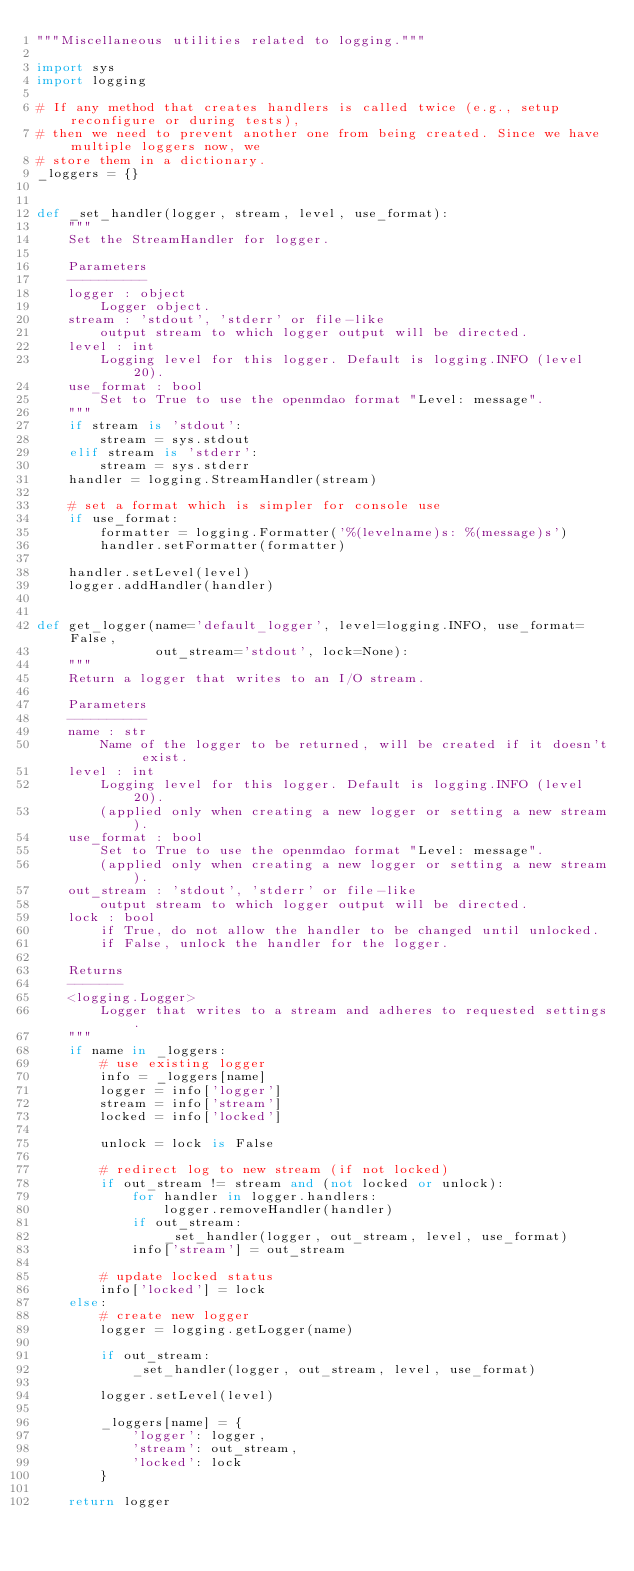<code> <loc_0><loc_0><loc_500><loc_500><_Python_>"""Miscellaneous utilities related to logging."""

import sys
import logging

# If any method that creates handlers is called twice (e.g., setup reconfigure or during tests),
# then we need to prevent another one from being created. Since we have multiple loggers now, we
# store them in a dictionary.
_loggers = {}


def _set_handler(logger, stream, level, use_format):
    """
    Set the StreamHandler for logger.

    Parameters
    ----------
    logger : object
        Logger object.
    stream : 'stdout', 'stderr' or file-like
        output stream to which logger output will be directed.
    level : int
        Logging level for this logger. Default is logging.INFO (level 20).
    use_format : bool
        Set to True to use the openmdao format "Level: message".
    """
    if stream is 'stdout':
        stream = sys.stdout
    elif stream is 'stderr':
        stream = sys.stderr
    handler = logging.StreamHandler(stream)

    # set a format which is simpler for console use
    if use_format:
        formatter = logging.Formatter('%(levelname)s: %(message)s')
        handler.setFormatter(formatter)

    handler.setLevel(level)
    logger.addHandler(handler)


def get_logger(name='default_logger', level=logging.INFO, use_format=False,
               out_stream='stdout', lock=None):
    """
    Return a logger that writes to an I/O stream.

    Parameters
    ----------
    name : str
        Name of the logger to be returned, will be created if it doesn't exist.
    level : int
        Logging level for this logger. Default is logging.INFO (level 20).
        (applied only when creating a new logger or setting a new stream).
    use_format : bool
        Set to True to use the openmdao format "Level: message".
        (applied only when creating a new logger or setting a new stream).
    out_stream : 'stdout', 'stderr' or file-like
        output stream to which logger output will be directed.
    lock : bool
        if True, do not allow the handler to be changed until unlocked.
        if False, unlock the handler for the logger.

    Returns
    -------
    <logging.Logger>
        Logger that writes to a stream and adheres to requested settings.
    """
    if name in _loggers:
        # use existing logger
        info = _loggers[name]
        logger = info['logger']
        stream = info['stream']
        locked = info['locked']

        unlock = lock is False

        # redirect log to new stream (if not locked)
        if out_stream != stream and (not locked or unlock):
            for handler in logger.handlers:
                logger.removeHandler(handler)
            if out_stream:
                _set_handler(logger, out_stream, level, use_format)
            info['stream'] = out_stream

        # update locked status
        info['locked'] = lock
    else:
        # create new logger
        logger = logging.getLogger(name)

        if out_stream:
            _set_handler(logger, out_stream, level, use_format)

        logger.setLevel(level)

        _loggers[name] = {
            'logger': logger,
            'stream': out_stream,
            'locked': lock
        }

    return logger
</code> 